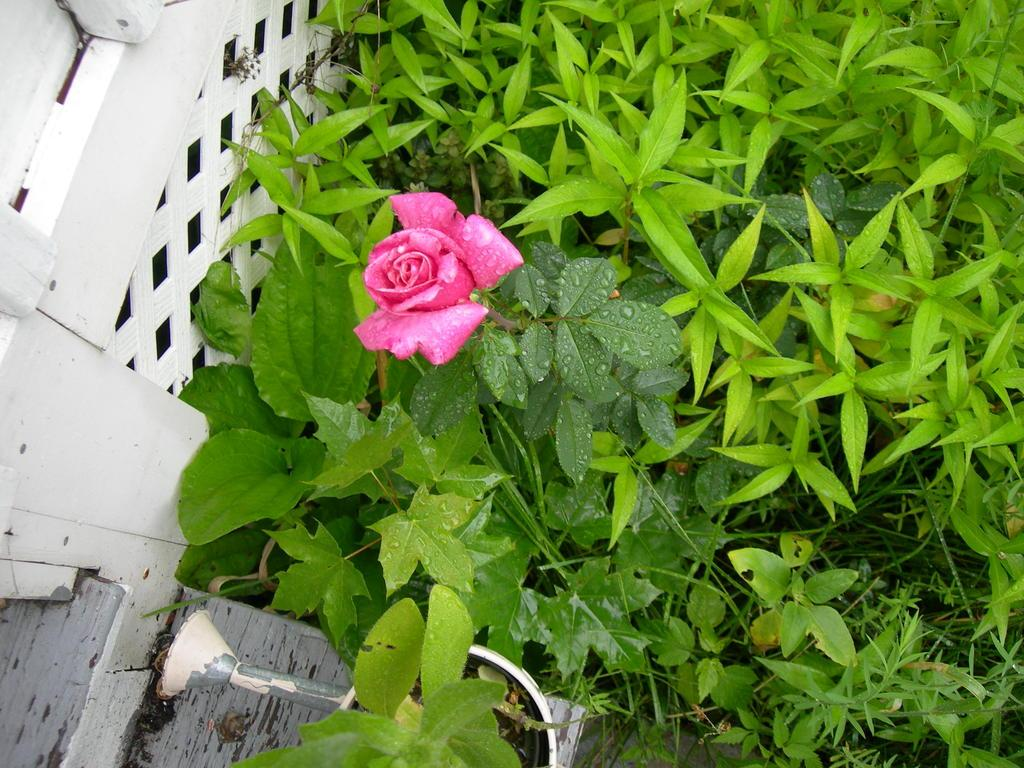What type of plant is visible in the picture? There is a flower in the picture. Are there any other plants in the picture besides the flower? Yes, there are plants in the picture. What type of structure can be seen in the background of the picture? There is a fence in the picture. What type of furniture is visible in the picture? There is no furniture present in the picture; it features a flower, plants, and a fence. What type of art can be seen on the fence in the picture? There is no art visible on the fence in the picture; it is a plain fence without any decorations or artwork. 